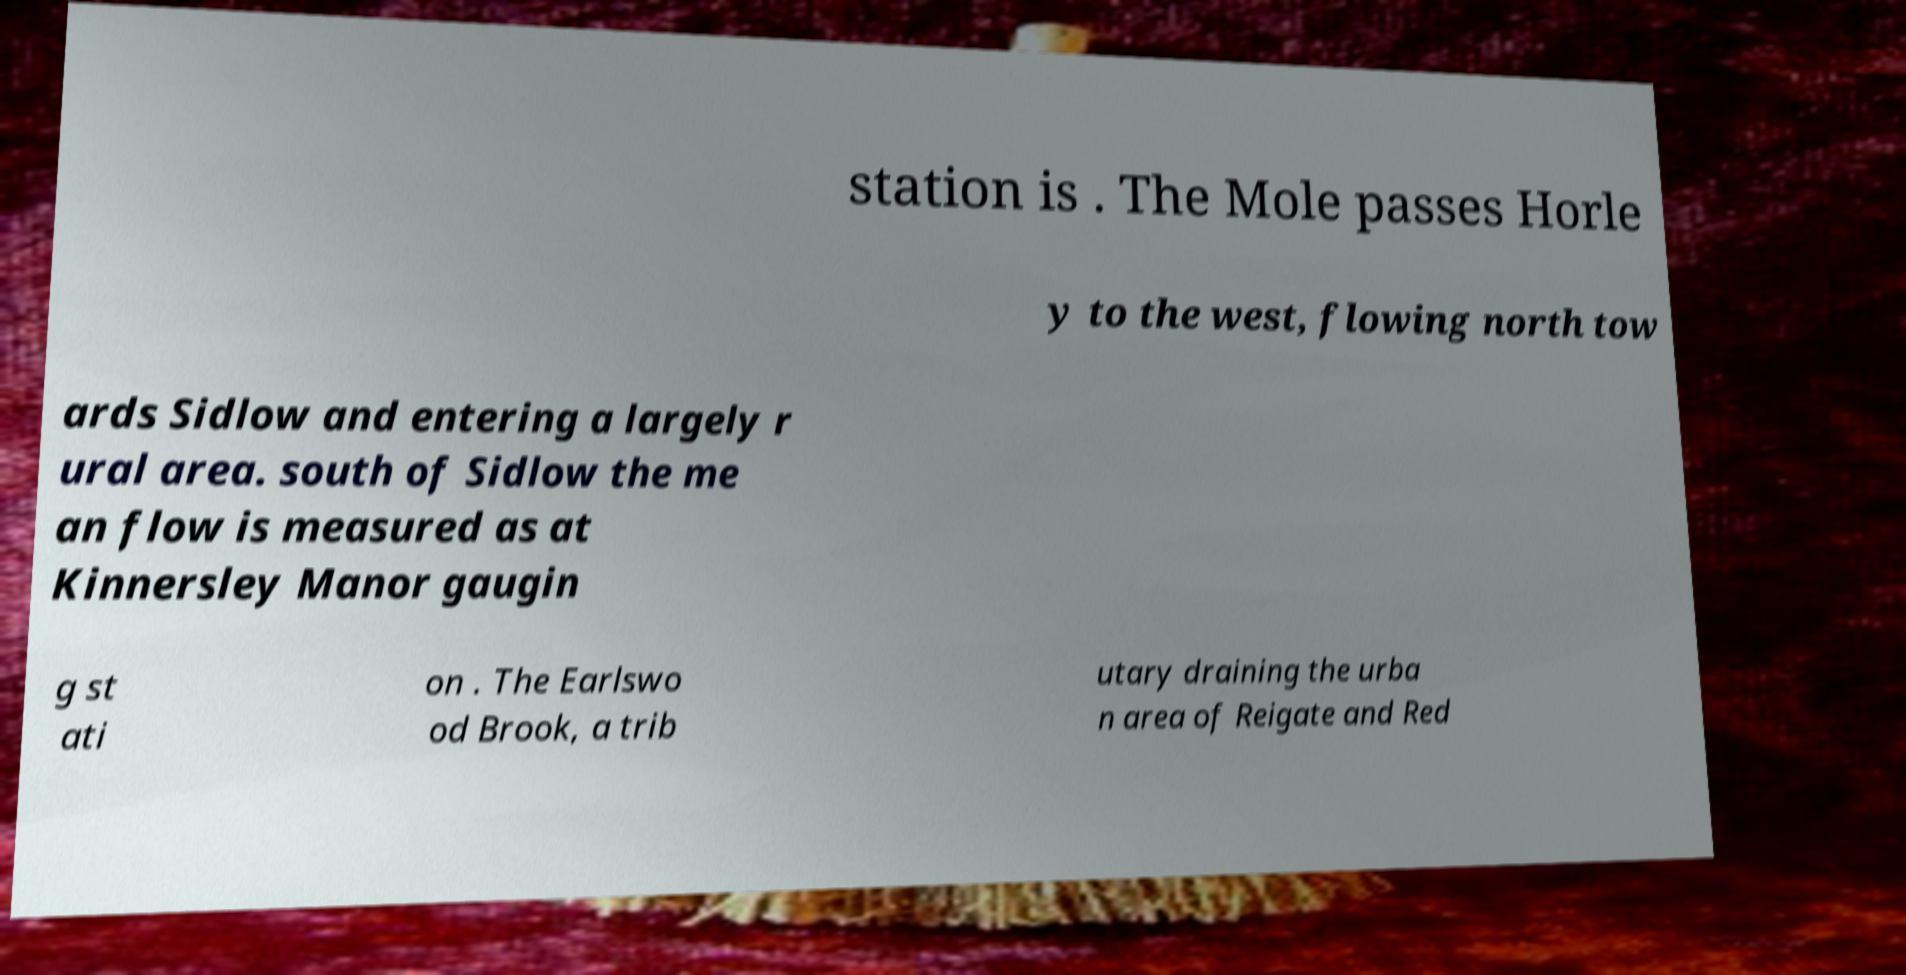Can you read and provide the text displayed in the image?This photo seems to have some interesting text. Can you extract and type it out for me? station is . The Mole passes Horle y to the west, flowing north tow ards Sidlow and entering a largely r ural area. south of Sidlow the me an flow is measured as at Kinnersley Manor gaugin g st ati on . The Earlswo od Brook, a trib utary draining the urba n area of Reigate and Red 